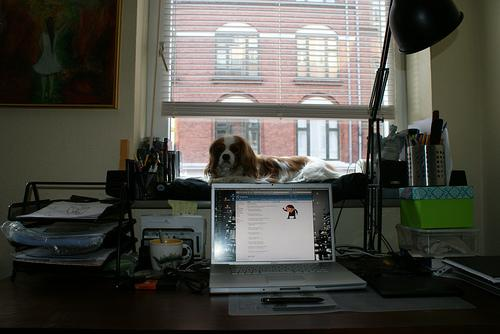What type of blinds are on the window in the image? There are mini blinds on the window. What is the color and state of the laptop computer in the image? The laptop computer is gray and turned on. List three objects found on the desk in the image. A laptop, paper organizer, and a coffee mug holding pens. What does the picture on the wall show? A little girl is in the picture on the wall. What is happening on the laptop screen? The laptop screen displays icons and a character on the desktop. What is the color of the building seen outside the window? The building outside the window is red. What is the purpose of the green and blue box in the image? The green and blue box is used to hold items and has a lid on it. Identify the object used to hold pens on the desk. A coffee mug is being used to hold pens. What breed of dog can be seen in the image? A King Charles Cavalier Spaniel is in the window. What type of lamp is located near the laptop? An extendable desk lamp that is turned off. Is the coffee mug filled with coffee and placed on top of the laptop? The coffee mug is actually being used to hold pens and is not filled with coffee or placed on top of the laptop. Find the object that corresponds to "a coffee mug being used to hold pens." X:151 Y:228 Width:42 Height:42 Rate the overall lighting in the image. The image has good lighting (7/10). Does the image give off a positive or negative sentiment? The image gives off a positive sentiment. Identify an unusual feature or element in the image that stands out. A coffee mug being used to hold pens. Describe the scene in the image. The image features a desk setting with a turned-on laptop, a dog sitting by the window, a desk lamp, two coffee mugs holding pens, a picture on the wall, a paper organizer, and a building outside the window. Does the desk lamp have a green shade? There is no information about the color of the desk lamp's shade in the provided data. List five objects that can be seen in the image. Laptop computer, desk lamp, coffee mug, dog, window blinds. Is the laptop screen turned on or off? The laptop screen is turned on. Is there any text visible in the image? No Is the building outside the window yellow? The building outside the window is described as being red, not yellow. Describe the attributes of the dog in the image. The dog is brown and white and appears to be a King Charles Cavalier spaniel. Are the blinds on the window opened or closed? The blinds on the window are closed. Is the picture of the little girl on the laptop screen? The picture of the little girl is actually on the wall, not on the laptop screen. How would you rate the quality of this image out of 10? 8 Which picture on the wall is bigger? The picture with dimensions X:1 Y:0 Width:117 Height:117 is bigger. Are the blinds in the room made of wood? There is no information about the material of the blinds, only that they exist in the room. What type of lamp is on the desk? An extendable desk lamp is on the desk. What color is the box holding the pencil cup? The box is green and blue. What is the color of the building outside the window? The building is red. Is the dog sitting on the desk next to the laptop? The dog is actually sitting in the window and not on the desk next to the laptop. Explain the interaction between the dog and the window. The dog is sitting by the window, possibly looking outside, suggesting it is observing or enjoying the view. How many filing trays are there on the desk? There are three filing trays on the desk. Identify what is inside the coffee mug on the desk. The coffee mug contains pens. 